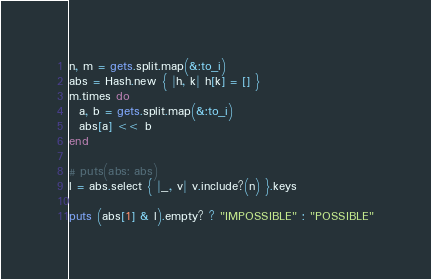<code> <loc_0><loc_0><loc_500><loc_500><_Ruby_>n, m = gets.split.map(&:to_i)
abs = Hash.new { |h, k| h[k] = [] }
m.times do
  a, b = gets.split.map(&:to_i)
  abs[a] << b
end

# puts(abs: abs)
l = abs.select { |_, v| v.include?(n) }.keys

puts (abs[1] & l).empty? ? "IMPOSSIBLE" : "POSSIBLE"
</code> 